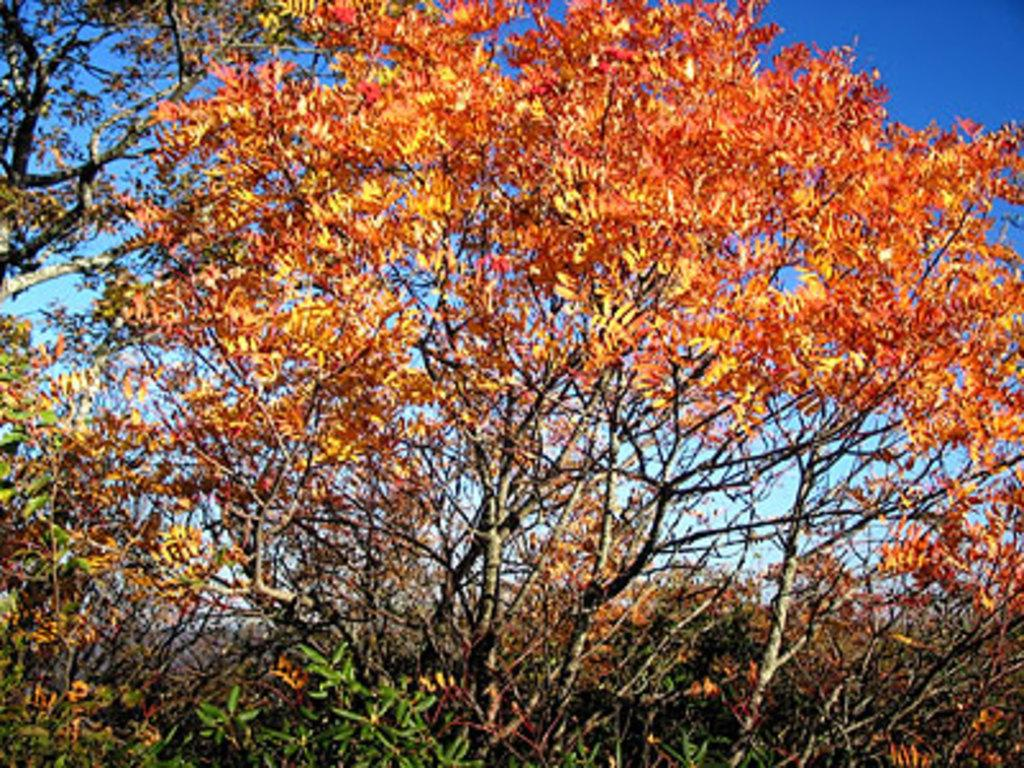What type of vegetation is present in the image? There are trees with leaves in the image. What structural components make up the trees? The trees have stems. What can be seen in the background of the image? The sky is visible in the background of the image. How many baseballs can be seen in the image? There are no baseballs present in the image. What type of test is being conducted in the image? There is no test being conducted in the image. 